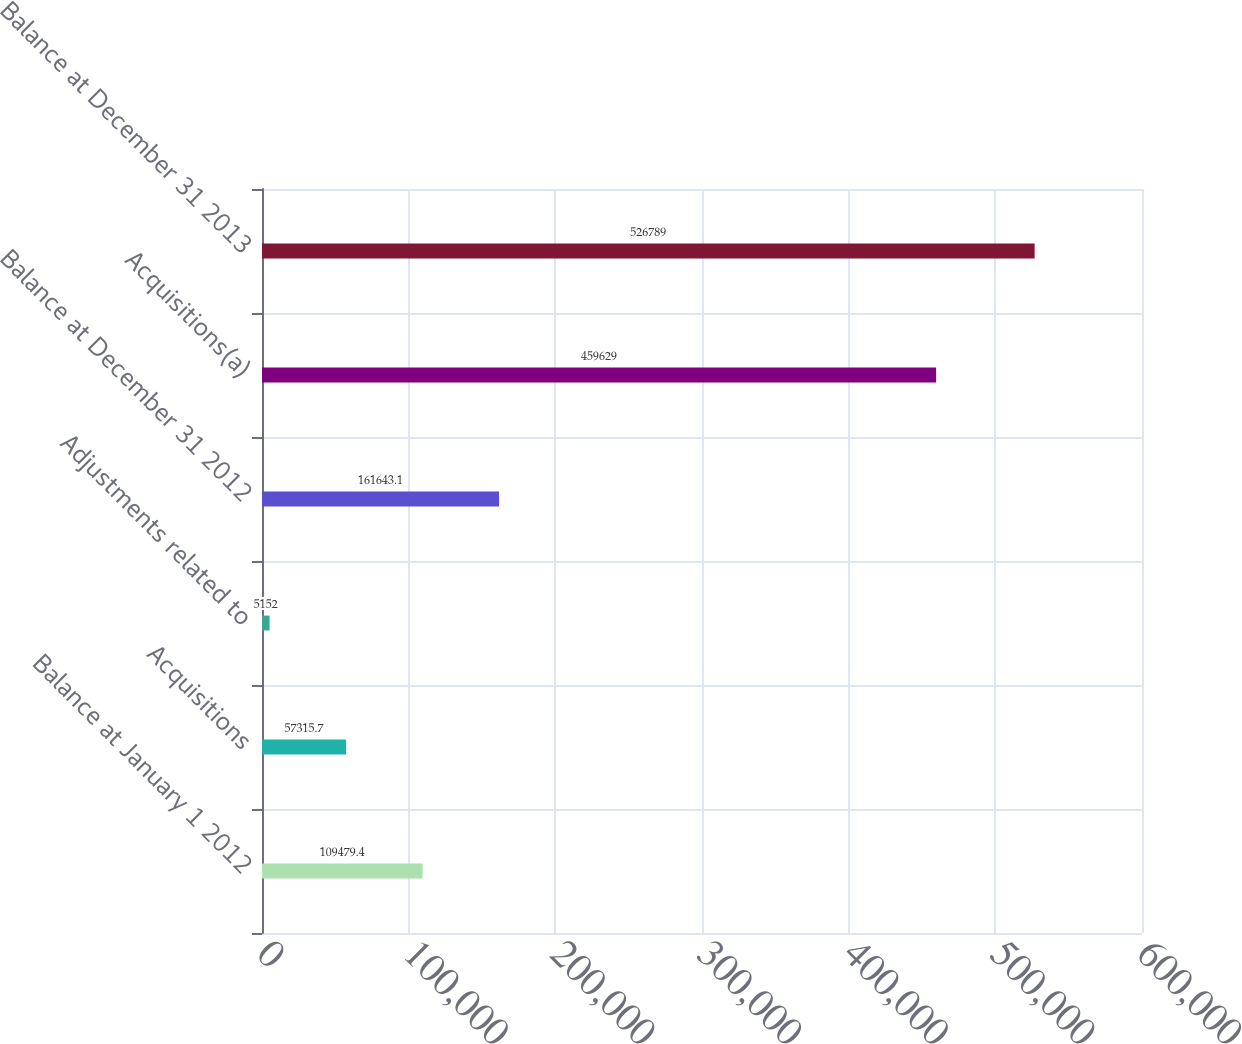Convert chart to OTSL. <chart><loc_0><loc_0><loc_500><loc_500><bar_chart><fcel>Balance at January 1 2012<fcel>Acquisitions<fcel>Adjustments related to<fcel>Balance at December 31 2012<fcel>Acquisitions(a)<fcel>Balance at December 31 2013<nl><fcel>109479<fcel>57315.7<fcel>5152<fcel>161643<fcel>459629<fcel>526789<nl></chart> 